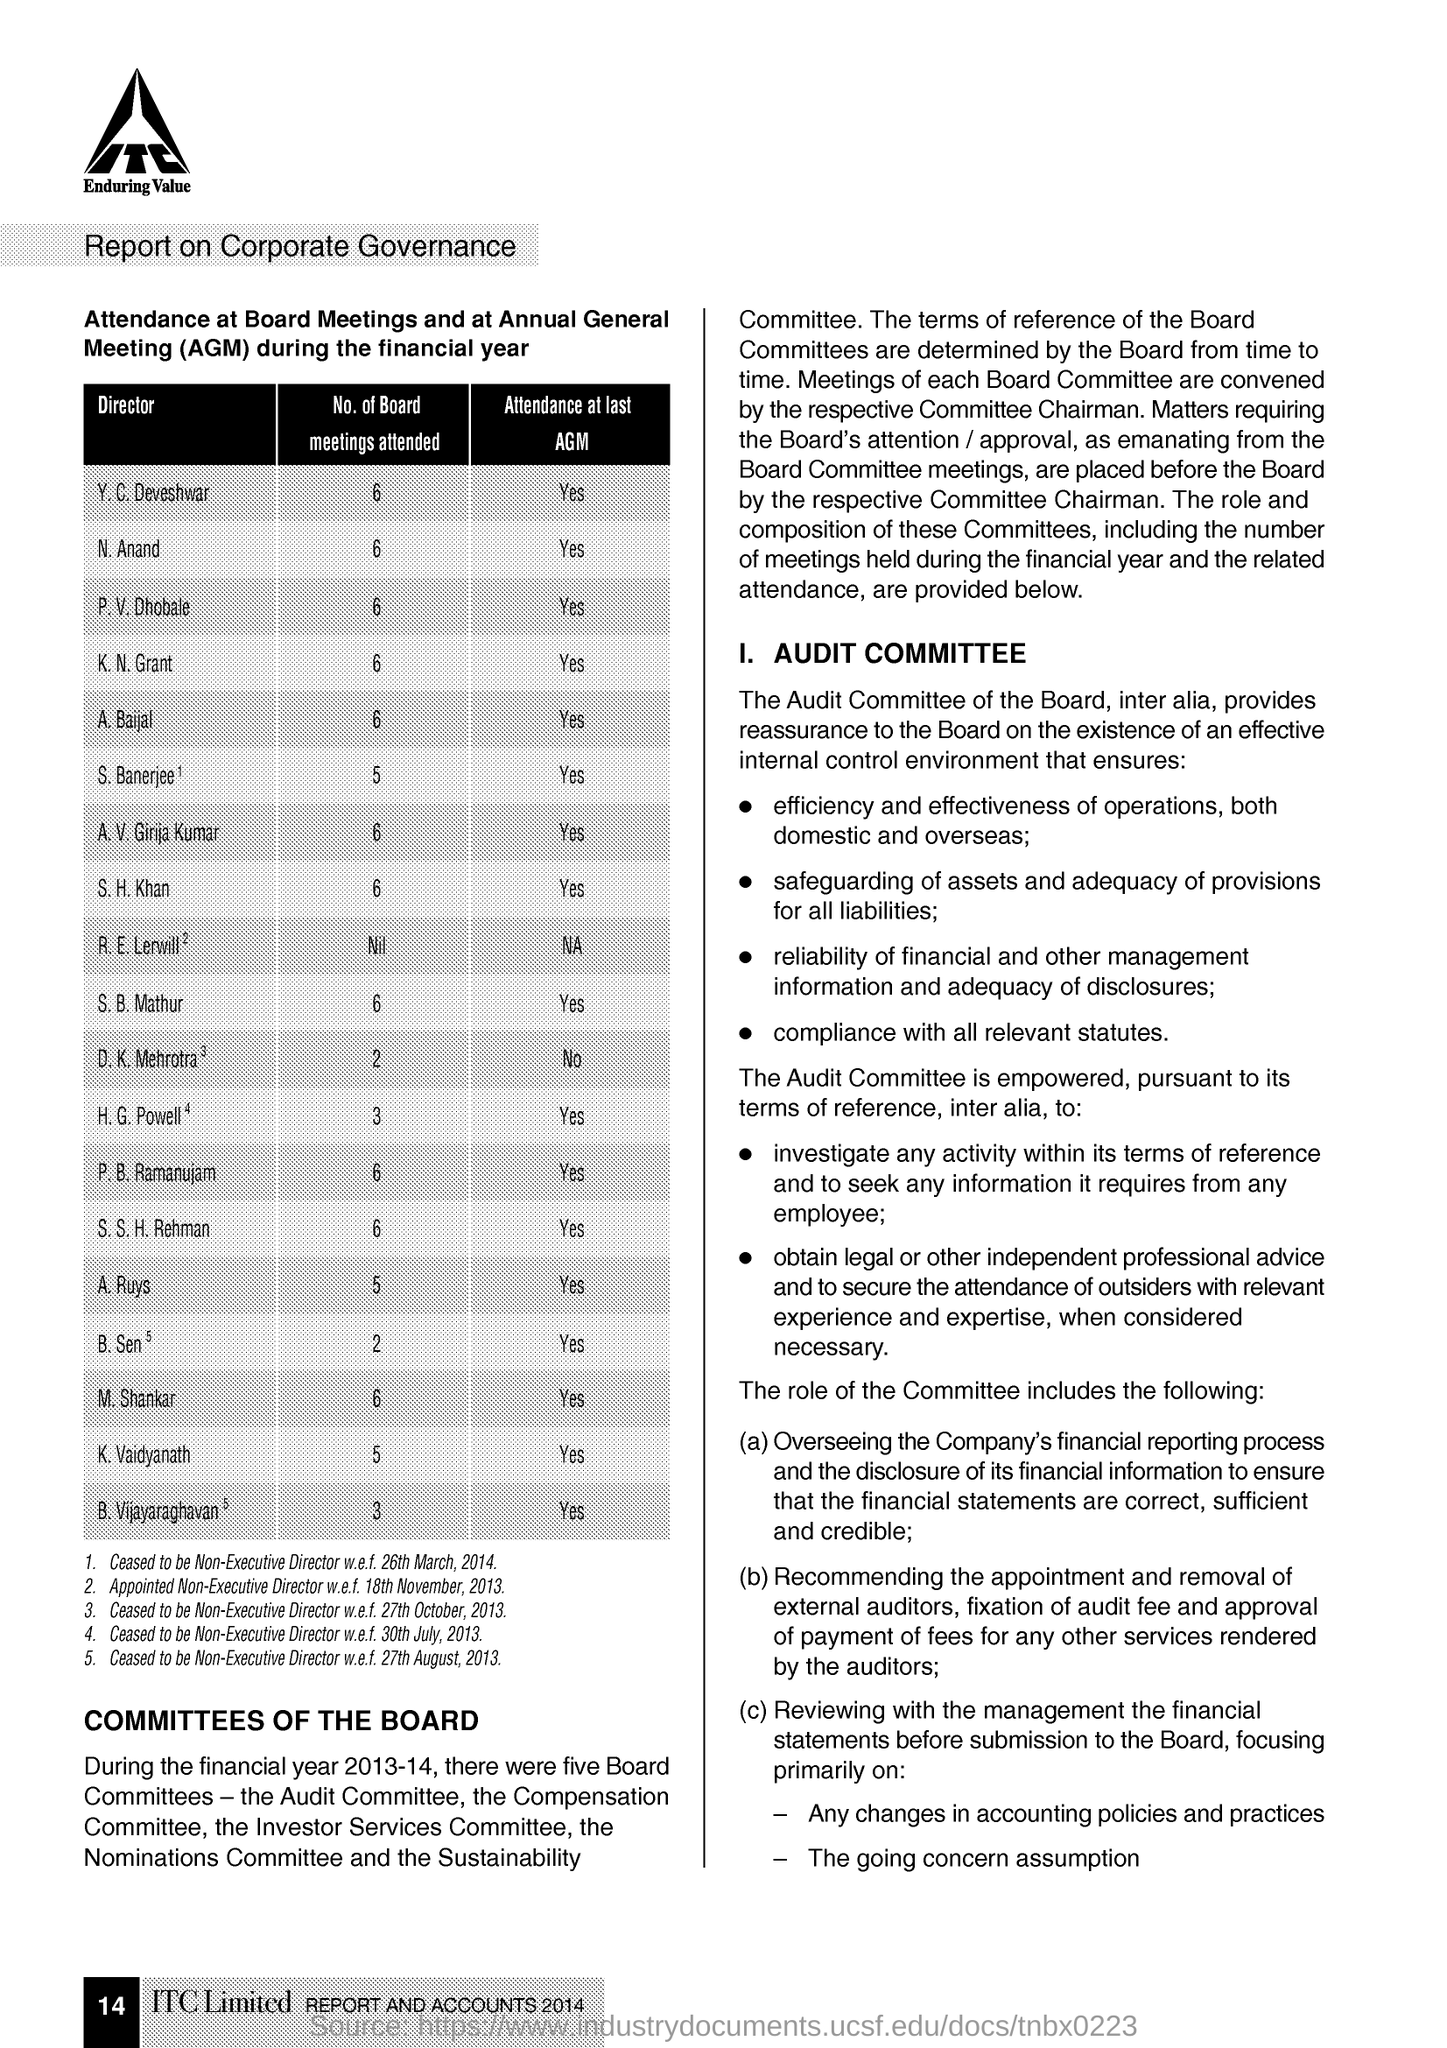What is the Fullform of AGM ?
Offer a terse response. Annual General Meeting. How many Board of meetings attended the N. Anand ?
Ensure brevity in your answer.  6. 